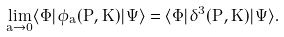Convert formula to latex. <formula><loc_0><loc_0><loc_500><loc_500>\lim _ { a \rightarrow 0 } \langle \Phi | \phi _ { a } ( \mathbf P , \mathbf K ) | \Psi \rangle = \langle \Phi | \delta ^ { 3 } ( \mathbf P , \mathbf K ) | \Psi \rangle .</formula> 